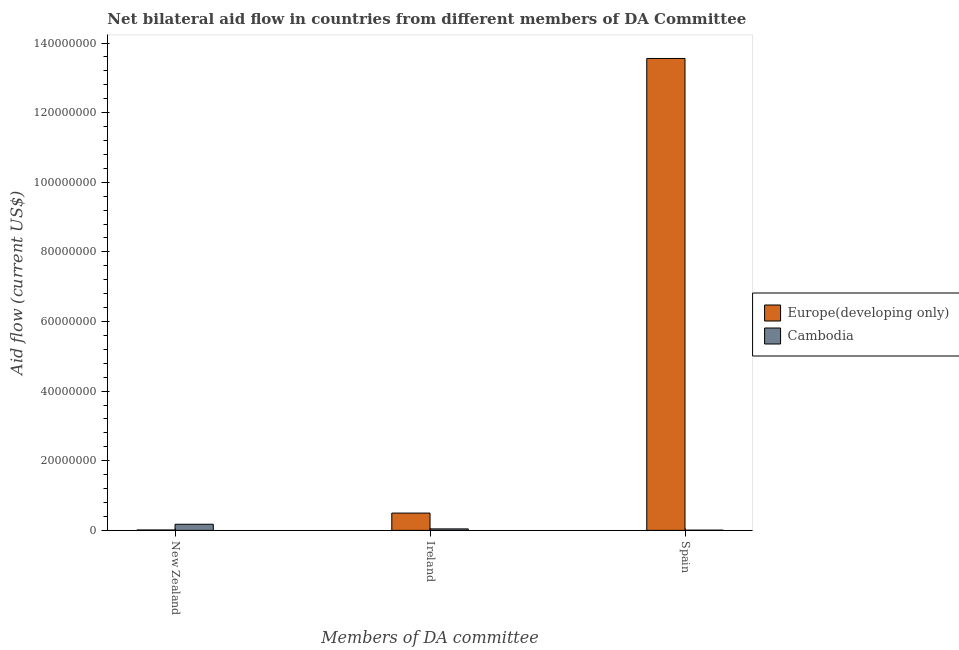How many different coloured bars are there?
Offer a very short reply. 2. Are the number of bars per tick equal to the number of legend labels?
Provide a short and direct response. Yes. Are the number of bars on each tick of the X-axis equal?
Make the answer very short. Yes. How many bars are there on the 1st tick from the right?
Your answer should be very brief. 2. What is the label of the 1st group of bars from the left?
Provide a succinct answer. New Zealand. What is the amount of aid provided by new zealand in Europe(developing only)?
Keep it short and to the point. 1.20e+05. Across all countries, what is the maximum amount of aid provided by spain?
Offer a terse response. 1.36e+08. Across all countries, what is the minimum amount of aid provided by ireland?
Keep it short and to the point. 4.30e+05. In which country was the amount of aid provided by ireland maximum?
Provide a succinct answer. Europe(developing only). In which country was the amount of aid provided by new zealand minimum?
Your answer should be very brief. Europe(developing only). What is the total amount of aid provided by spain in the graph?
Your answer should be very brief. 1.36e+08. What is the difference between the amount of aid provided by spain in Cambodia and that in Europe(developing only)?
Your answer should be compact. -1.35e+08. What is the difference between the amount of aid provided by spain in Cambodia and the amount of aid provided by new zealand in Europe(developing only)?
Make the answer very short. -5.00e+04. What is the average amount of aid provided by new zealand per country?
Your answer should be very brief. 9.40e+05. What is the difference between the amount of aid provided by new zealand and amount of aid provided by spain in Europe(developing only)?
Offer a very short reply. -1.35e+08. In how many countries, is the amount of aid provided by new zealand greater than 64000000 US$?
Make the answer very short. 0. What is the ratio of the amount of aid provided by ireland in Cambodia to that in Europe(developing only)?
Offer a terse response. 0.09. Is the difference between the amount of aid provided by new zealand in Cambodia and Europe(developing only) greater than the difference between the amount of aid provided by spain in Cambodia and Europe(developing only)?
Make the answer very short. Yes. What is the difference between the highest and the second highest amount of aid provided by ireland?
Offer a very short reply. 4.54e+06. What is the difference between the highest and the lowest amount of aid provided by ireland?
Give a very brief answer. 4.54e+06. Is the sum of the amount of aid provided by ireland in Europe(developing only) and Cambodia greater than the maximum amount of aid provided by new zealand across all countries?
Provide a succinct answer. Yes. What does the 2nd bar from the left in Spain represents?
Keep it short and to the point. Cambodia. What does the 2nd bar from the right in Ireland represents?
Offer a very short reply. Europe(developing only). Are all the bars in the graph horizontal?
Ensure brevity in your answer.  No. How many countries are there in the graph?
Your answer should be very brief. 2. What is the difference between two consecutive major ticks on the Y-axis?
Make the answer very short. 2.00e+07. Does the graph contain any zero values?
Make the answer very short. No. Does the graph contain grids?
Provide a short and direct response. No. What is the title of the graph?
Your answer should be compact. Net bilateral aid flow in countries from different members of DA Committee. What is the label or title of the X-axis?
Make the answer very short. Members of DA committee. What is the Aid flow (current US$) in Cambodia in New Zealand?
Your response must be concise. 1.76e+06. What is the Aid flow (current US$) in Europe(developing only) in Ireland?
Keep it short and to the point. 4.97e+06. What is the Aid flow (current US$) in Europe(developing only) in Spain?
Your answer should be compact. 1.36e+08. What is the Aid flow (current US$) of Cambodia in Spain?
Give a very brief answer. 7.00e+04. Across all Members of DA committee, what is the maximum Aid flow (current US$) in Europe(developing only)?
Make the answer very short. 1.36e+08. Across all Members of DA committee, what is the maximum Aid flow (current US$) of Cambodia?
Your response must be concise. 1.76e+06. Across all Members of DA committee, what is the minimum Aid flow (current US$) in Europe(developing only)?
Offer a very short reply. 1.20e+05. Across all Members of DA committee, what is the minimum Aid flow (current US$) in Cambodia?
Your response must be concise. 7.00e+04. What is the total Aid flow (current US$) in Europe(developing only) in the graph?
Your answer should be compact. 1.41e+08. What is the total Aid flow (current US$) in Cambodia in the graph?
Provide a succinct answer. 2.26e+06. What is the difference between the Aid flow (current US$) in Europe(developing only) in New Zealand and that in Ireland?
Give a very brief answer. -4.85e+06. What is the difference between the Aid flow (current US$) of Cambodia in New Zealand and that in Ireland?
Offer a terse response. 1.33e+06. What is the difference between the Aid flow (current US$) in Europe(developing only) in New Zealand and that in Spain?
Offer a terse response. -1.35e+08. What is the difference between the Aid flow (current US$) of Cambodia in New Zealand and that in Spain?
Ensure brevity in your answer.  1.69e+06. What is the difference between the Aid flow (current US$) of Europe(developing only) in Ireland and that in Spain?
Provide a short and direct response. -1.31e+08. What is the difference between the Aid flow (current US$) in Europe(developing only) in New Zealand and the Aid flow (current US$) in Cambodia in Ireland?
Your answer should be very brief. -3.10e+05. What is the difference between the Aid flow (current US$) in Europe(developing only) in New Zealand and the Aid flow (current US$) in Cambodia in Spain?
Provide a succinct answer. 5.00e+04. What is the difference between the Aid flow (current US$) in Europe(developing only) in Ireland and the Aid flow (current US$) in Cambodia in Spain?
Your answer should be very brief. 4.90e+06. What is the average Aid flow (current US$) of Europe(developing only) per Members of DA committee?
Your answer should be compact. 4.69e+07. What is the average Aid flow (current US$) in Cambodia per Members of DA committee?
Offer a terse response. 7.53e+05. What is the difference between the Aid flow (current US$) in Europe(developing only) and Aid flow (current US$) in Cambodia in New Zealand?
Your answer should be compact. -1.64e+06. What is the difference between the Aid flow (current US$) of Europe(developing only) and Aid flow (current US$) of Cambodia in Ireland?
Keep it short and to the point. 4.54e+06. What is the difference between the Aid flow (current US$) of Europe(developing only) and Aid flow (current US$) of Cambodia in Spain?
Offer a terse response. 1.35e+08. What is the ratio of the Aid flow (current US$) in Europe(developing only) in New Zealand to that in Ireland?
Your answer should be compact. 0.02. What is the ratio of the Aid flow (current US$) of Cambodia in New Zealand to that in Ireland?
Ensure brevity in your answer.  4.09. What is the ratio of the Aid flow (current US$) in Europe(developing only) in New Zealand to that in Spain?
Keep it short and to the point. 0. What is the ratio of the Aid flow (current US$) of Cambodia in New Zealand to that in Spain?
Offer a terse response. 25.14. What is the ratio of the Aid flow (current US$) of Europe(developing only) in Ireland to that in Spain?
Your answer should be very brief. 0.04. What is the ratio of the Aid flow (current US$) in Cambodia in Ireland to that in Spain?
Ensure brevity in your answer.  6.14. What is the difference between the highest and the second highest Aid flow (current US$) in Europe(developing only)?
Offer a very short reply. 1.31e+08. What is the difference between the highest and the second highest Aid flow (current US$) in Cambodia?
Keep it short and to the point. 1.33e+06. What is the difference between the highest and the lowest Aid flow (current US$) of Europe(developing only)?
Your answer should be compact. 1.35e+08. What is the difference between the highest and the lowest Aid flow (current US$) in Cambodia?
Provide a short and direct response. 1.69e+06. 